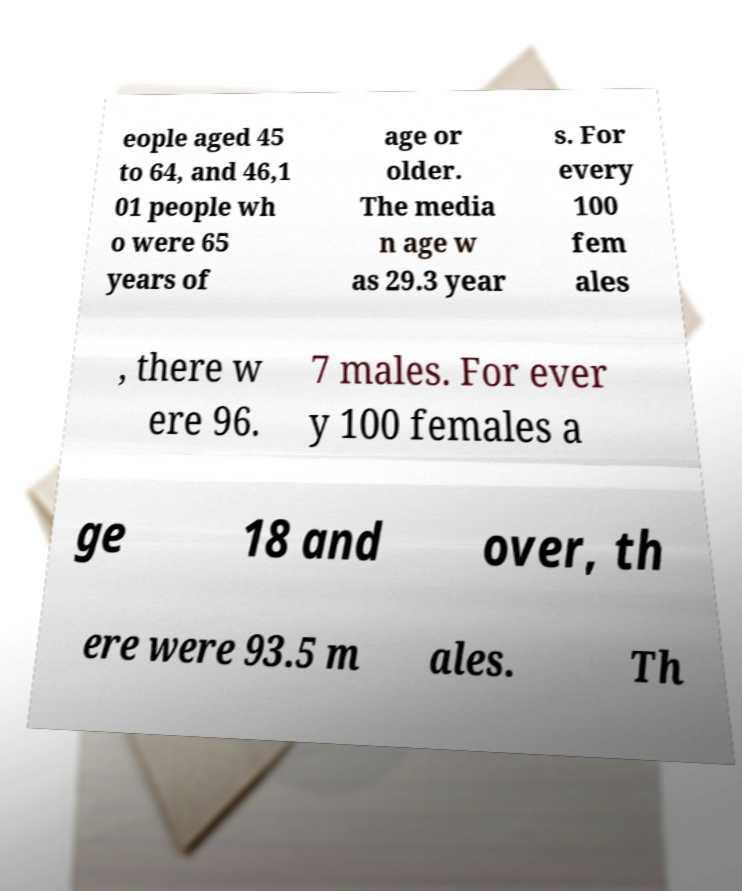Could you assist in decoding the text presented in this image and type it out clearly? eople aged 45 to 64, and 46,1 01 people wh o were 65 years of age or older. The media n age w as 29.3 year s. For every 100 fem ales , there w ere 96. 7 males. For ever y 100 females a ge 18 and over, th ere were 93.5 m ales. Th 